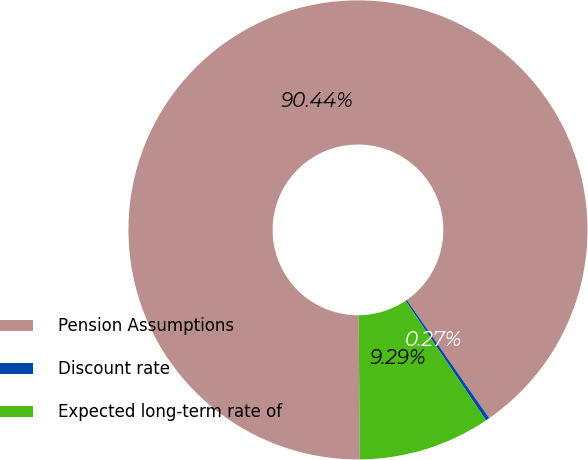Convert chart. <chart><loc_0><loc_0><loc_500><loc_500><pie_chart><fcel>Pension Assumptions<fcel>Discount rate<fcel>Expected long-term rate of<nl><fcel>90.44%<fcel>0.27%<fcel>9.29%<nl></chart> 